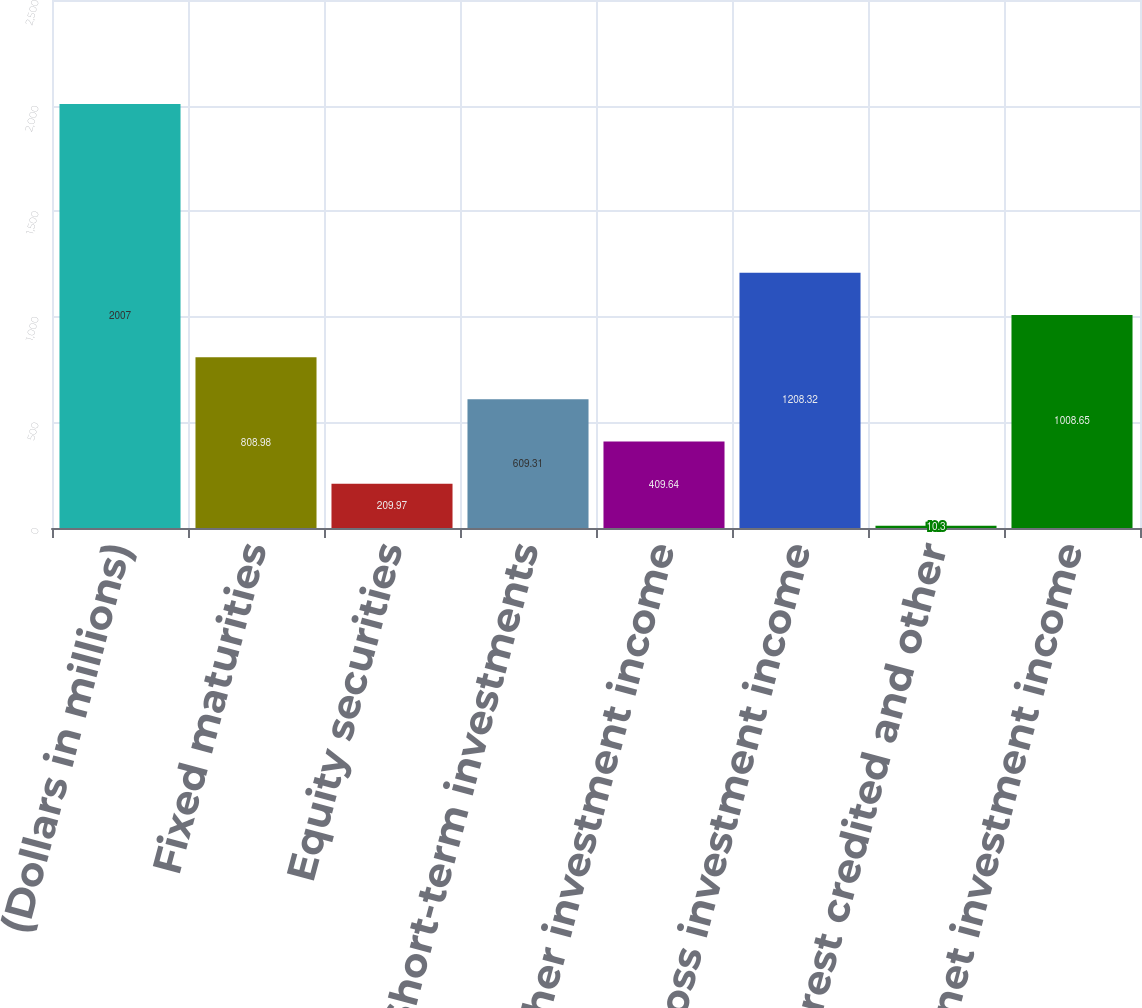Convert chart. <chart><loc_0><loc_0><loc_500><loc_500><bar_chart><fcel>(Dollars in millions)<fcel>Fixed maturities<fcel>Equity securities<fcel>Short-term investments<fcel>Other investment income<fcel>Total gross investment income<fcel>Interest credited and other<fcel>Total net investment income<nl><fcel>2007<fcel>808.98<fcel>209.97<fcel>609.31<fcel>409.64<fcel>1208.32<fcel>10.3<fcel>1008.65<nl></chart> 